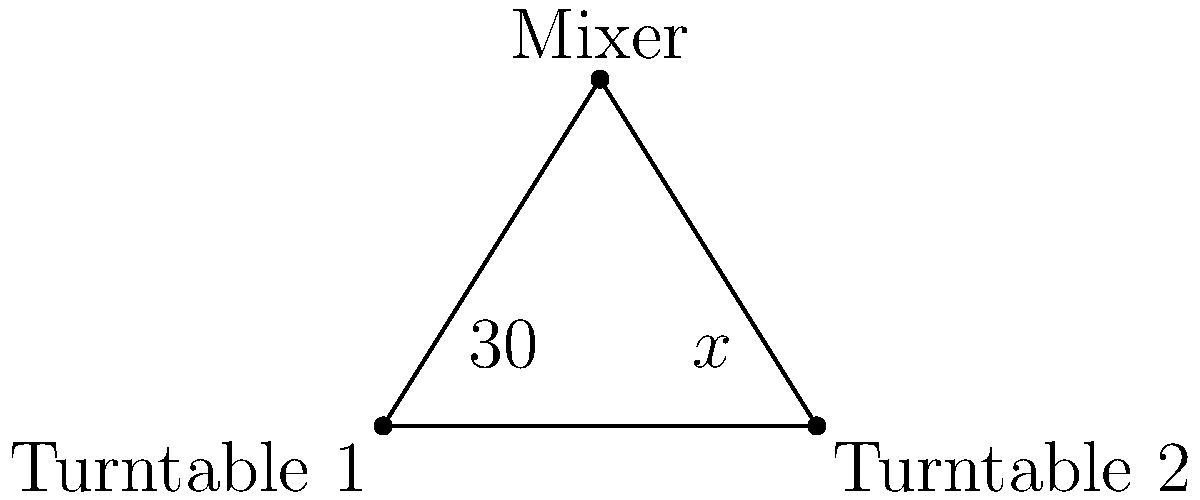In a classic DJ setup, two turntables are positioned at the base of an isosceles triangle, with the mixer at the apex. If the angle between one turntable and the mixer is 30°, what is the angle (x°) between the other turntable and the mixer? Let's approach this step-by-step:

1) In an isosceles triangle, the base angles are equal. This means that the angles between each turntable and the mixer are the same.

2) We know that one of these angles is 30°.

3) In any triangle, the sum of all internal angles is always 180°.

4) Let's call the angle at the apex (where the mixer is) y°. We can now set up an equation:

   $30° + 30° + y° = 180°$

5) Simplifying:
   
   $60° + y° = 180°$

6) Solving for y:

   $y° = 180° - 60° = 120°$

7) Now, we know that the angle at the apex (mixer) is 120°.

8) Since we're asked about the angle x°, which is one of the base angles, we can find it by subtracting the known base angle from 180° and dividing by 2:

   $x° = (180° - 120°) ÷ 2 = 60° ÷ 2 = 30°$

Therefore, the angle x° is also 30°.
Answer: 30° 